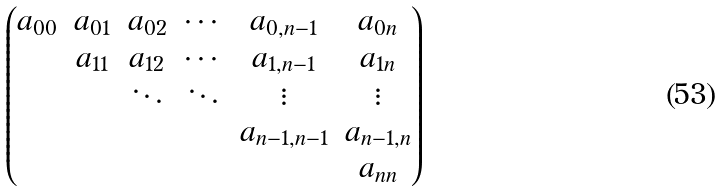<formula> <loc_0><loc_0><loc_500><loc_500>\begin{pmatrix} a _ { 0 0 } & a _ { 0 1 } & a _ { 0 2 } & \cdots & a _ { 0 , n - 1 } & a _ { 0 n } \\ & a _ { 1 1 } & a _ { 1 2 } & \cdots & a _ { 1 , n - 1 } & a _ { 1 n } \\ & & \ddots & \ddots & \vdots & \vdots \\ & & & & a _ { n - 1 , n - 1 } & a _ { n - 1 , n } \\ & & & & & a _ { n n } \end{pmatrix}</formula> 